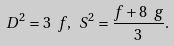<formula> <loc_0><loc_0><loc_500><loc_500>D ^ { 2 } = 3 \ f , \ S ^ { 2 } = \frac { f + 8 \ g } { 3 } .</formula> 